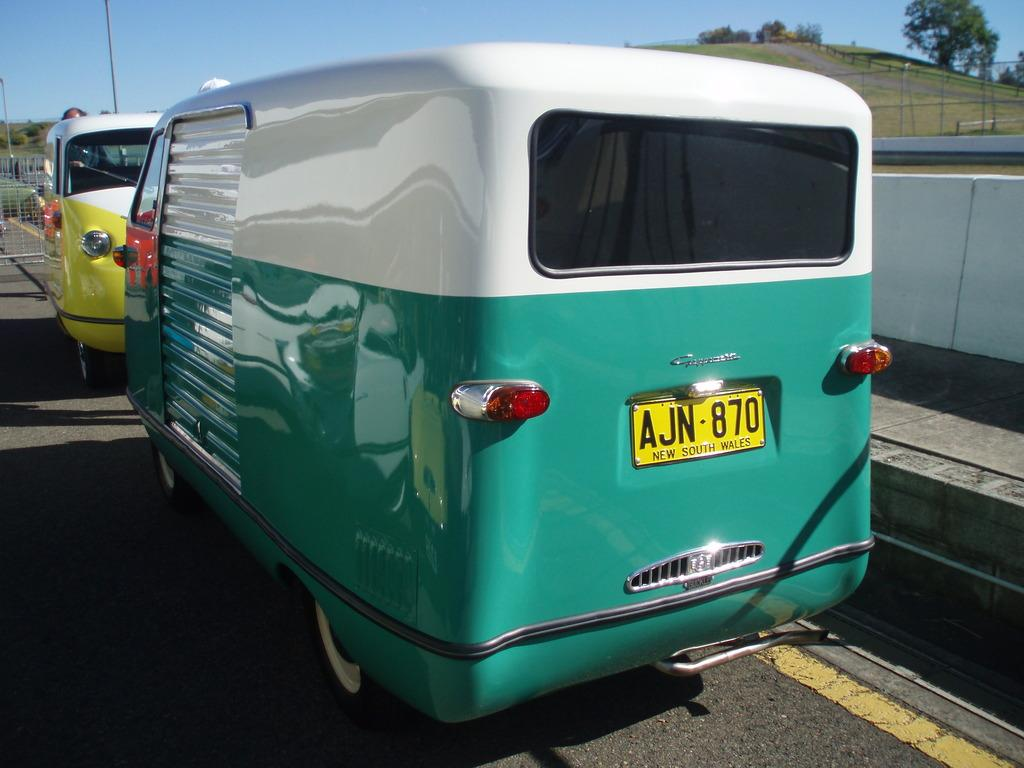<image>
Share a concise interpretation of the image provided. A little bus on the road with the New South Wales registration AJN-870. 